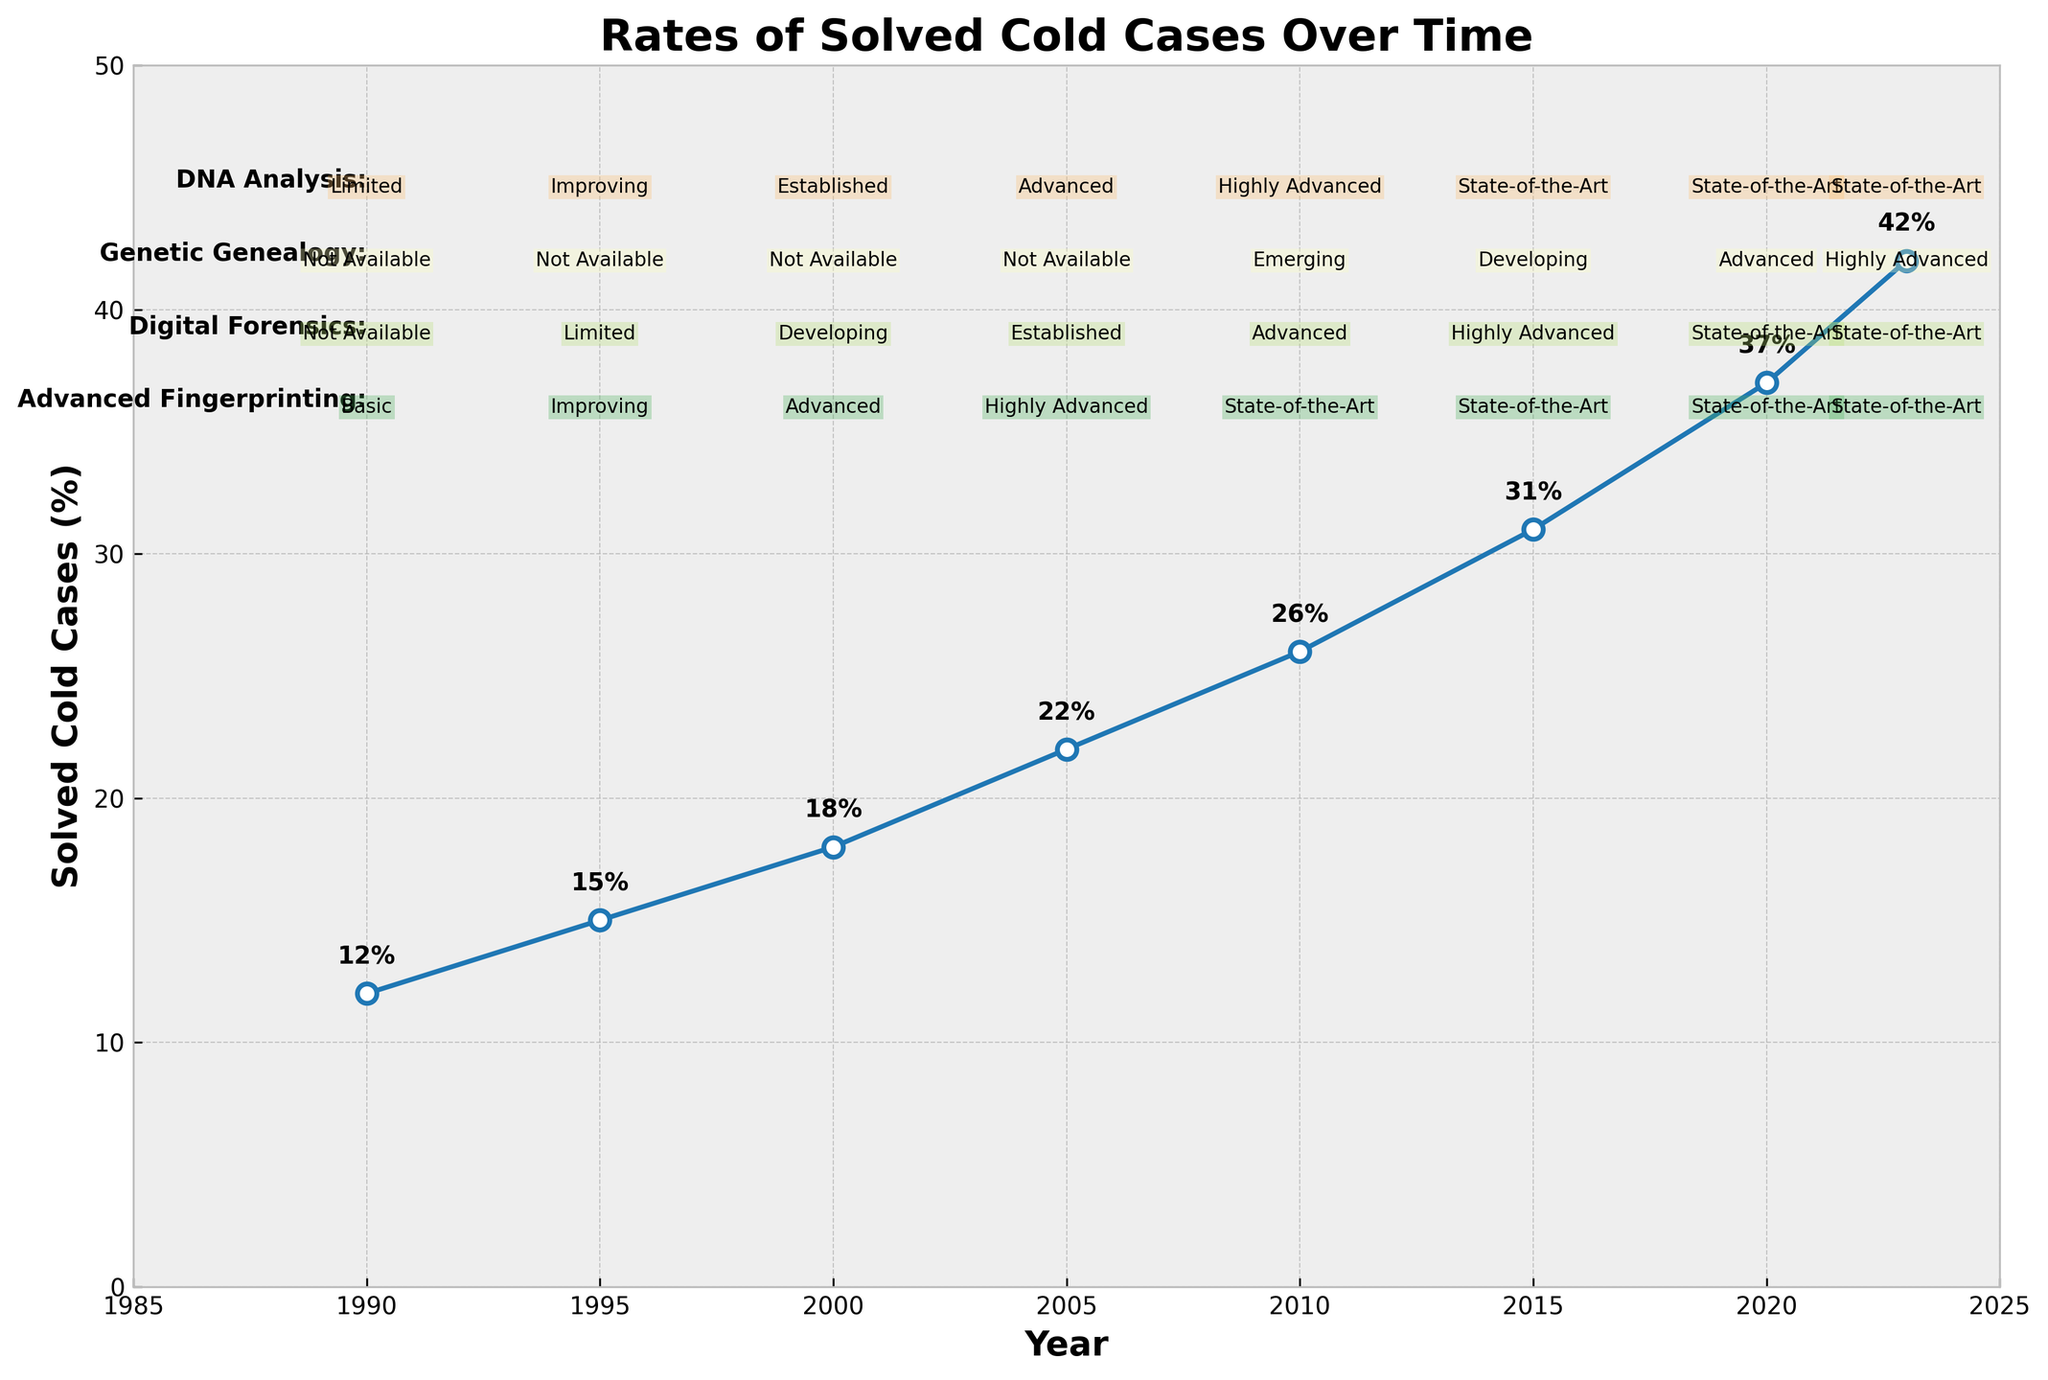What is the trend of solved cold cases over time? The rate of solved cold cases shows a steady increase from 12% in 1990 to 42% in 2023, indicating continuous improvement over the years.
Answer: Steady increase Which years saw an increase of 5% or more in solved cold cases compared to the previous data point? By comparing the rates between consecutive years: 1995 to 2000 increased by 3%, 2000 to 2005 increased by 4%, 2005 to 2010 increased by 4%, 2010 to 2015 increased by 5%, 2015 to 2020 increased by 6%, and 2020 to 2023 increased by 5%. Therefore, 2010 to 2015 and 2015 to 2020 saw increases of 5% or more.
Answer: 2010 to 2015, 2015 to 2020 What's the percentage increase in solved cold cases from 1990 to 2023? The percentage increase can be calculated using the formula: ((new value - old value) / old value) * 100. So, ((42 - 12) / 12) * 100 = 250%.
Answer: 250% When did DNA analysis become "State-of-the-Art"? DNA analysis is first labeled "State-of-the-Art" in 2010, as indicated in the visual attributes listed alongside the years.
Answer: 2010 Compare the rate of solved cold cases in 2005 and 2020. The rate in 2005 is 22%, and in 2020, it is 37%. Subtracting 22 from 37 gives an increase of 15 percentage points.
Answer: 15 percentage points increase During which period did Genetic Genealogy transition from "Not Available" to "Emerging"? According to the chart, Genetic Genealogy transitions from "Not Available" to "Emerging" between 2005 and 2010.
Answer: 2005 to 2010 Is there a correlation between advances in Digital Forensics and the increase in solved cold cases? Digital Forensics shows a transition from "Not Available" to "Developing" around 2000. As it becomes "Advanced" and "State-of-the-Art" by 2020, there is a noticeable increase in solved cold cases, indicating a potential correlation.
Answer: Yes What is the difference in solved cold cases percentage between 1990 and 2010? In 1990, the solved rate is 12%, and in 2010, it is 26%. Subtracting 12 from 26 gives a difference of 14 percentage points.
Answer: 14 percentage points How has Advanced Fingerprinting evolved from 1990 to 2023? Initially labeled as "Basic" in 1990, Advanced Fingerprinting progresses to "Improving" by 1995, "Advanced" by 2000, "Highly Advanced" by 2005, and "State-of-the-Art" by 2010, maintaining this status through 2023.
Answer: Evolved to State-of-the-Art 